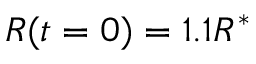<formula> <loc_0><loc_0><loc_500><loc_500>R ( t = 0 ) = 1 . 1 R ^ { * }</formula> 